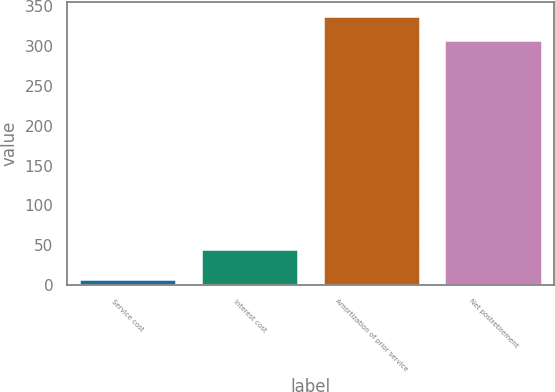Convert chart to OTSL. <chart><loc_0><loc_0><loc_500><loc_500><bar_chart><fcel>Service cost<fcel>Interest cost<fcel>Amortization of prior service<fcel>Net postretirement<nl><fcel>8<fcel>45<fcel>338.3<fcel>308<nl></chart> 